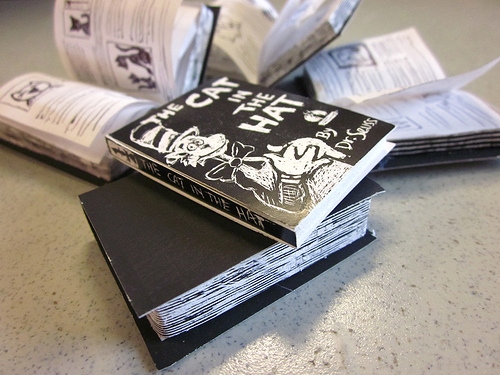<image>
Is the book in the book? No. The book is not contained within the book. These objects have a different spatial relationship. 